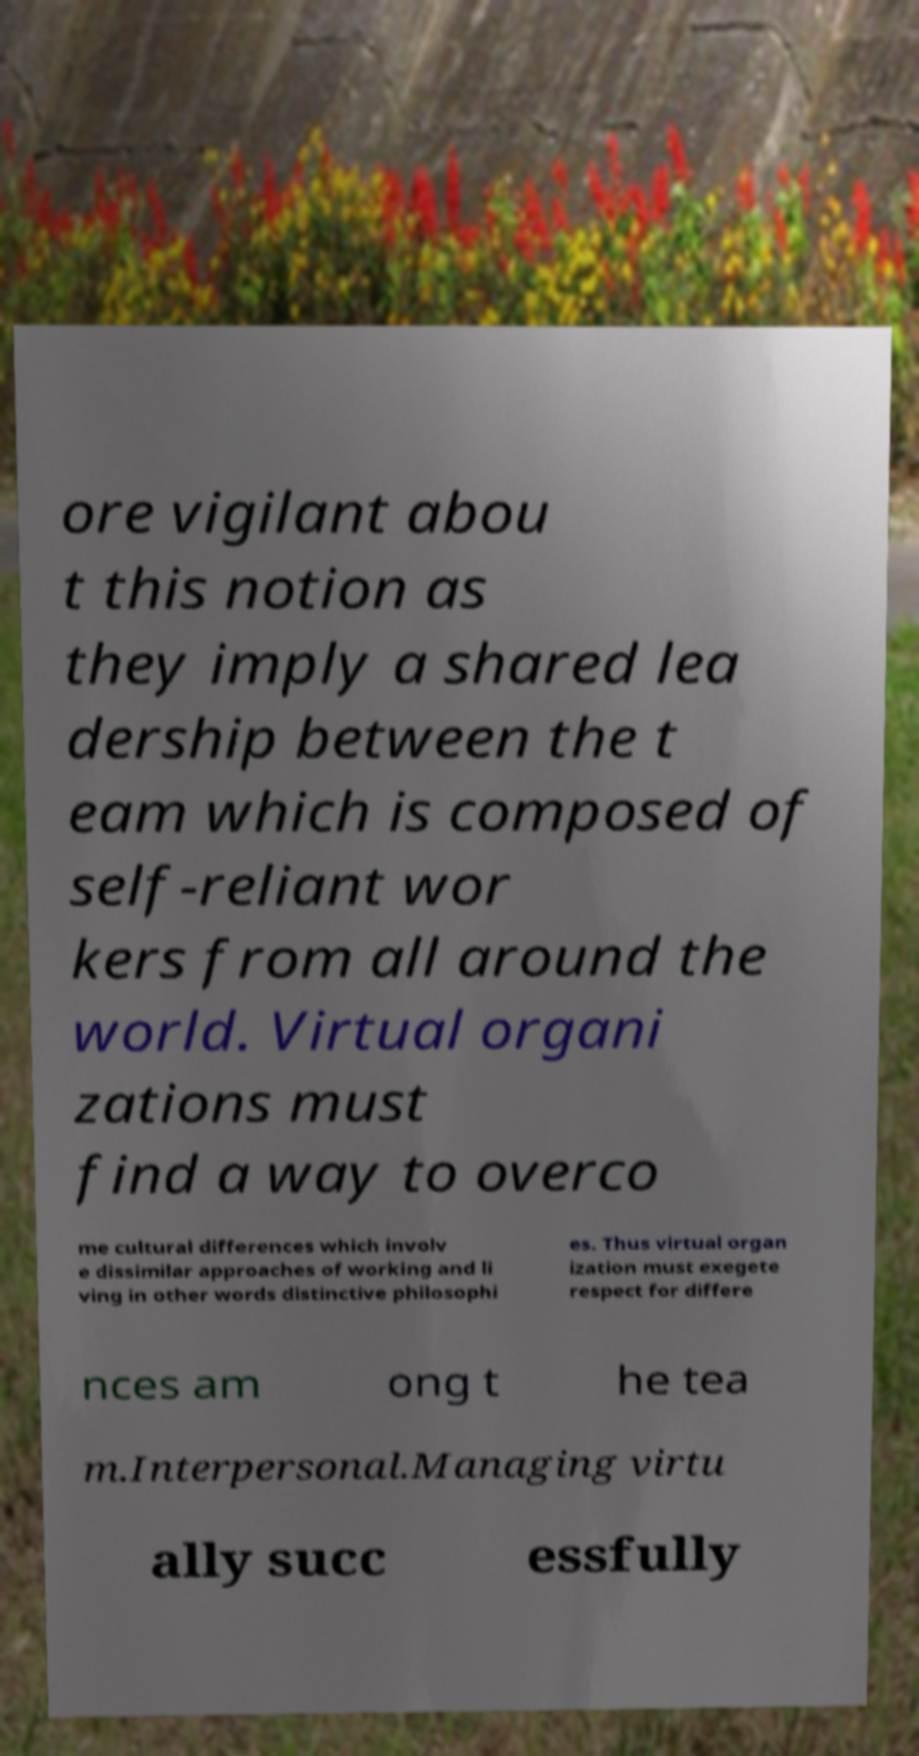Could you extract and type out the text from this image? ore vigilant abou t this notion as they imply a shared lea dership between the t eam which is composed of self-reliant wor kers from all around the world. Virtual organi zations must find a way to overco me cultural differences which involv e dissimilar approaches of working and li ving in other words distinctive philosophi es. Thus virtual organ ization must exegete respect for differe nces am ong t he tea m.Interpersonal.Managing virtu ally succ essfully 